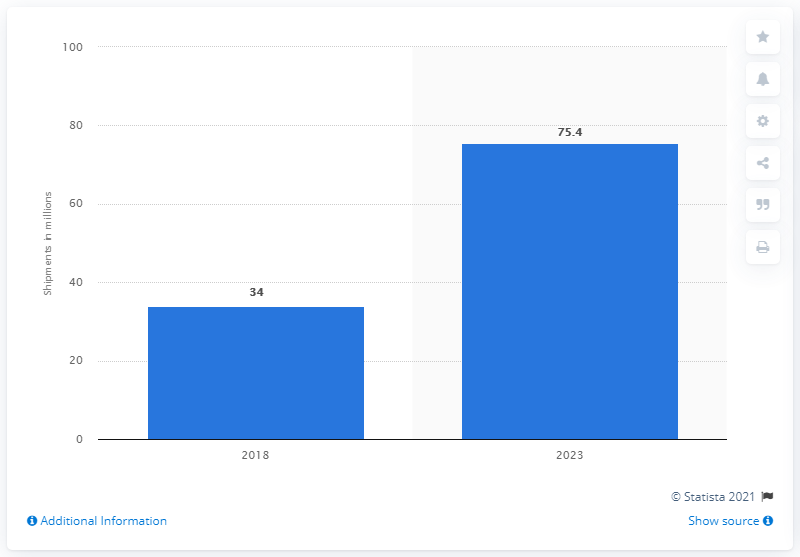Highlight a few significant elements in this photo. By 2024, it is expected that the volume of embedded OEM telematics systems will be 75.4%. 